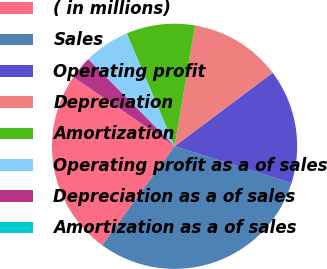Convert chart to OTSL. <chart><loc_0><loc_0><loc_500><loc_500><pie_chart><fcel>( in millions)<fcel>Sales<fcel>Operating profit<fcel>Depreciation<fcel>Amortization<fcel>Operating profit as a of sales<fcel>Depreciation as a of sales<fcel>Amortization as a of sales<nl><fcel>24.48%<fcel>30.19%<fcel>15.1%<fcel>12.08%<fcel>9.06%<fcel>6.05%<fcel>3.03%<fcel>0.01%<nl></chart> 